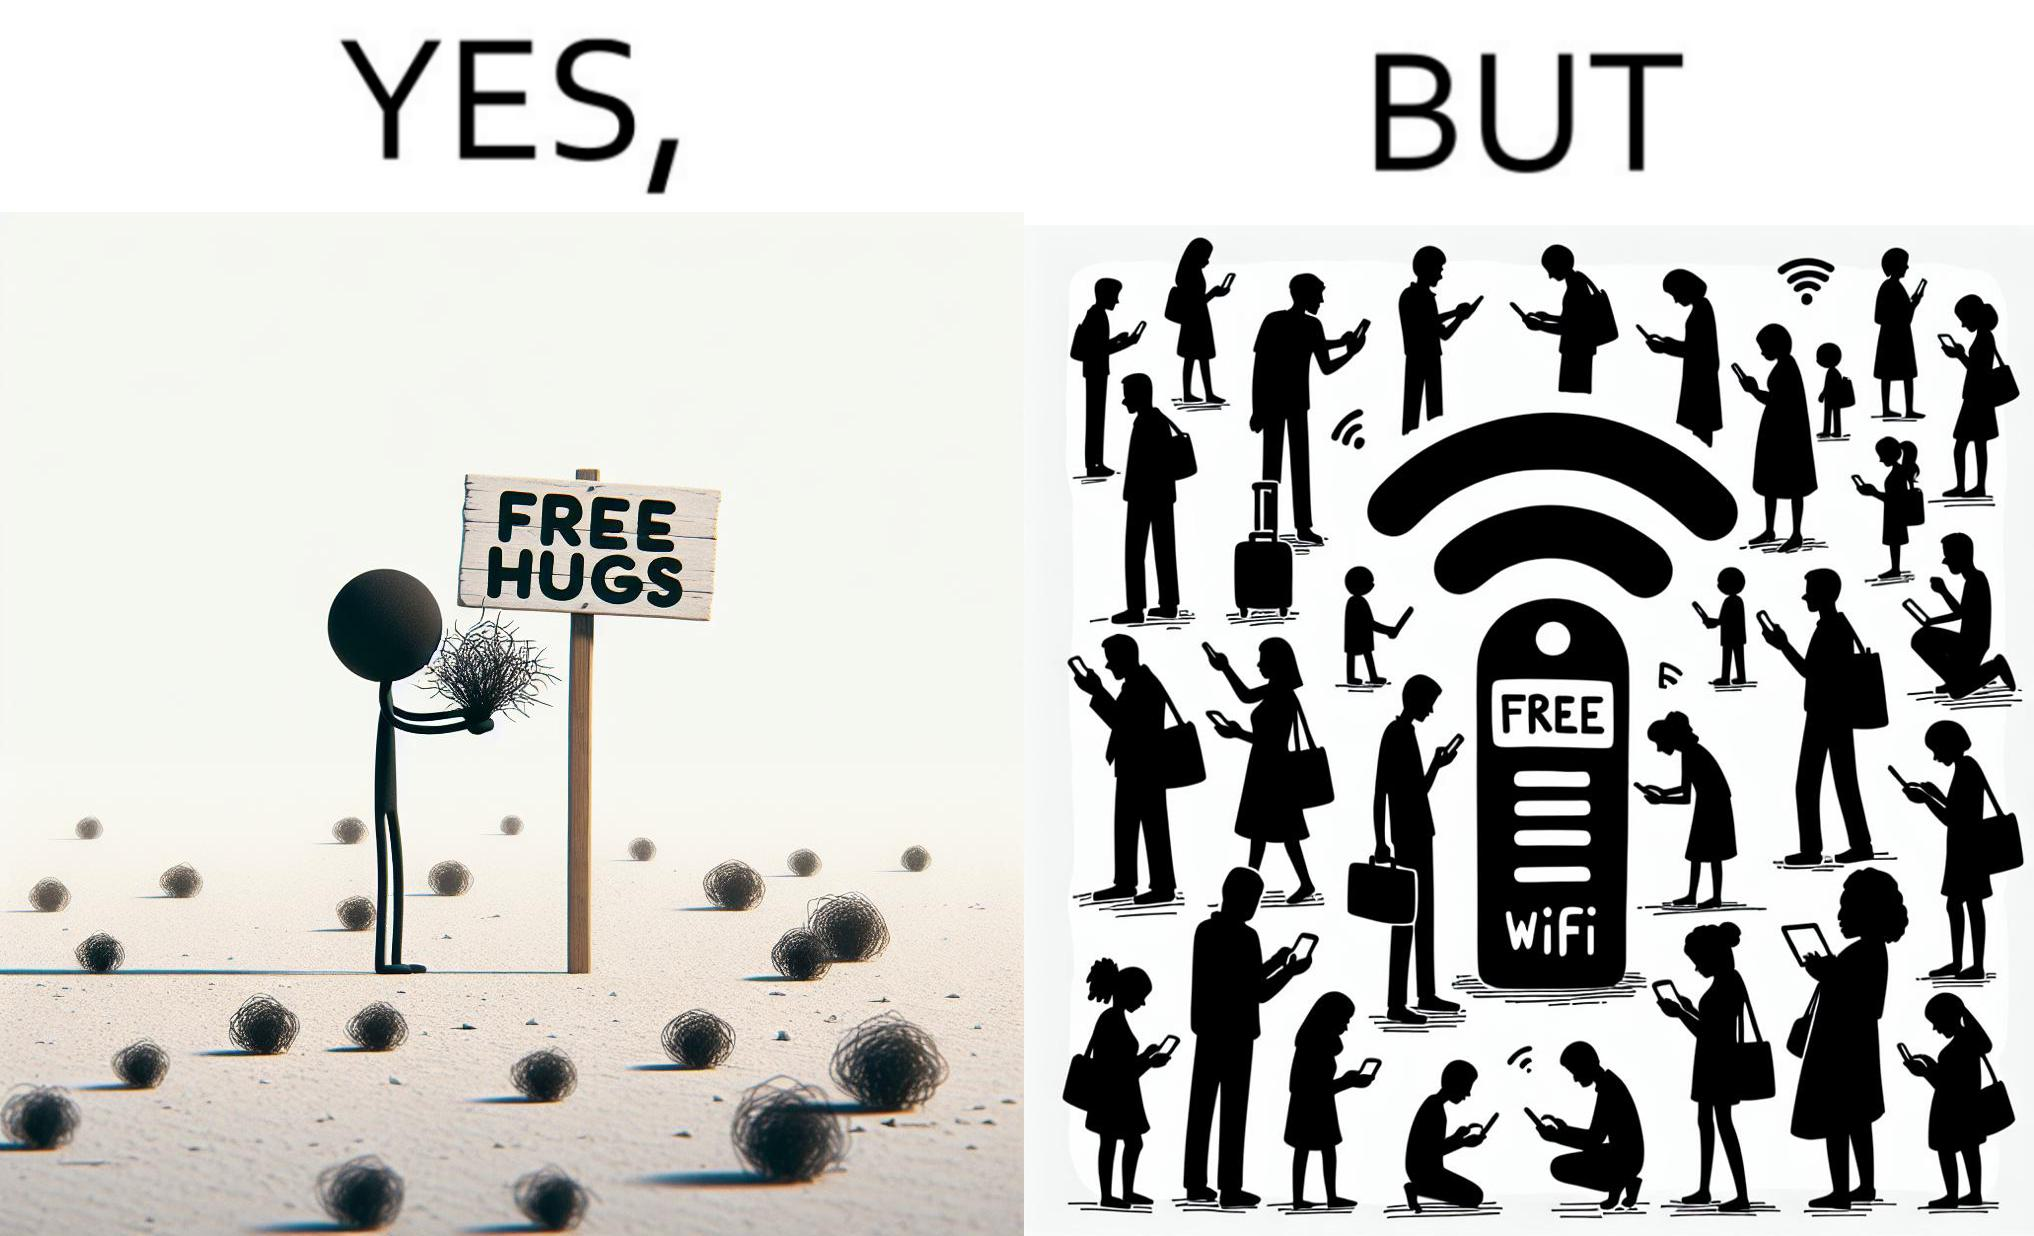Explain why this image is satirical. This image is ironical, as a person holding up a "Free Hugs" sign is standing alone, while an inanimate Wi-fi Router giving "Free Wifi" is surrounded people trying to connect to it. This shows a growing lack of empathy in our society, while showing our increasing dependence on the digital devices in a virtual world. 